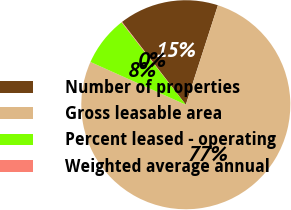Convert chart to OTSL. <chart><loc_0><loc_0><loc_500><loc_500><pie_chart><fcel>Number of properties<fcel>Gross leasable area<fcel>Percent leased - operating<fcel>Weighted average annual<nl><fcel>15.42%<fcel>76.74%<fcel>7.75%<fcel>0.09%<nl></chart> 